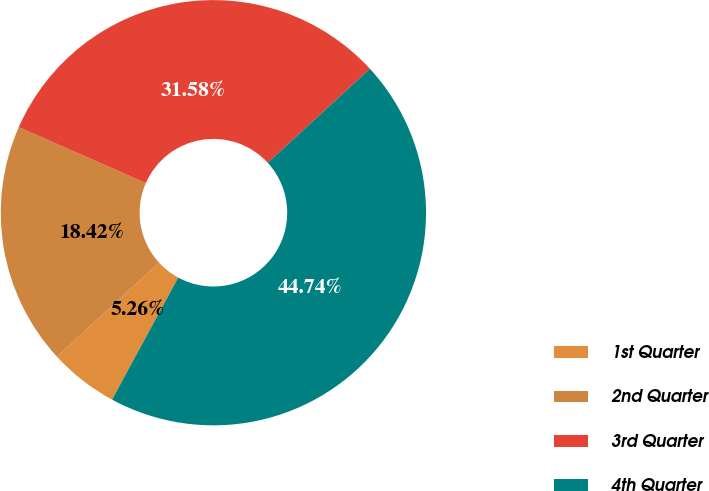Convert chart to OTSL. <chart><loc_0><loc_0><loc_500><loc_500><pie_chart><fcel>1st Quarter<fcel>2nd Quarter<fcel>3rd Quarter<fcel>4th Quarter<nl><fcel>5.26%<fcel>18.42%<fcel>31.58%<fcel>44.74%<nl></chart> 